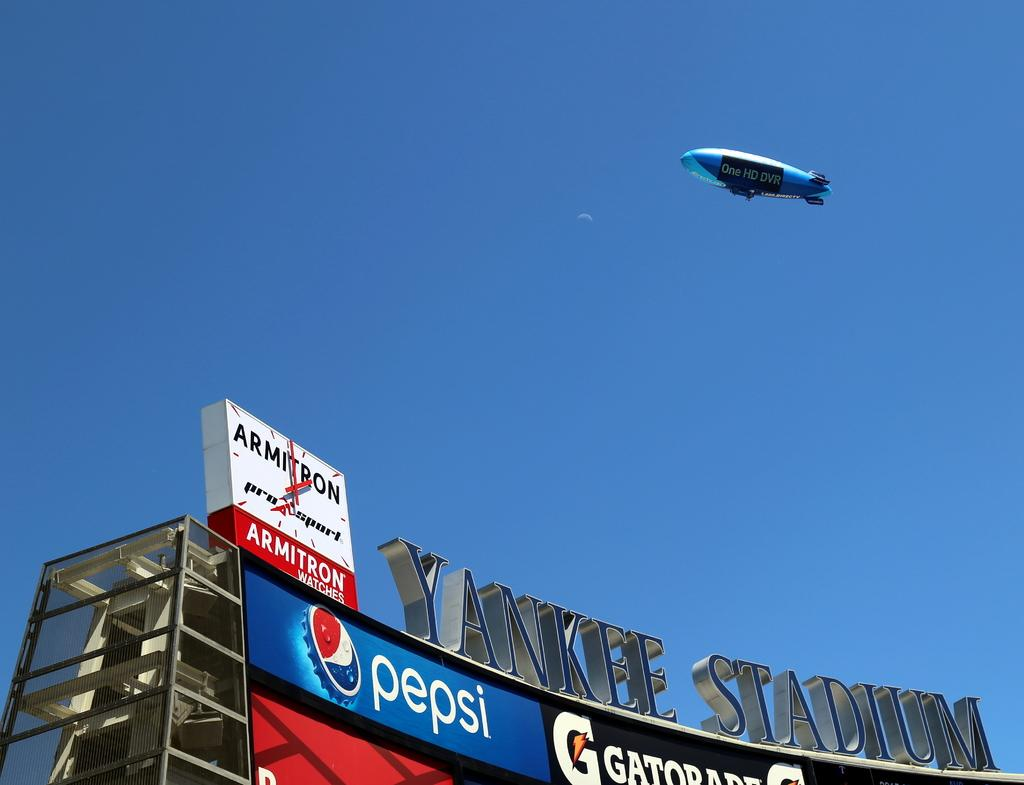What is located in the foreground of the image? There is a group of sign boards and a clock in the foreground of the image. What can be seen in the sky in the background of the image? An airship is flying in the sky in the background of the image. What type of cream is being used to paint the sign boards in the image? There is no indication in the image that the sign boards are being painted, nor is there any mention of cream being used. 